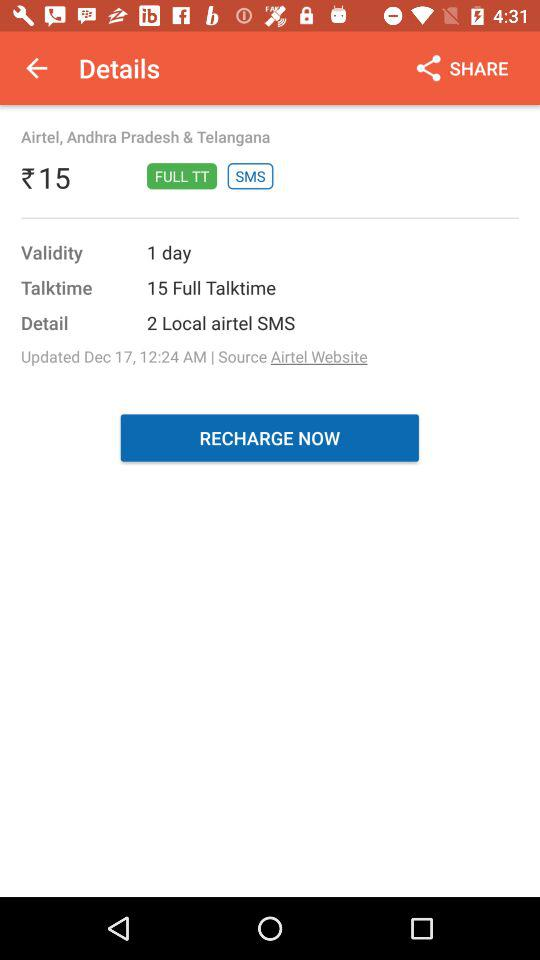What is the price of the full talktime plan? The price of the full talktime plan is ₹15. 